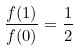Convert formula to latex. <formula><loc_0><loc_0><loc_500><loc_500>\frac { f ( 1 ) } { f ( 0 ) } = \frac { 1 } { 2 }</formula> 